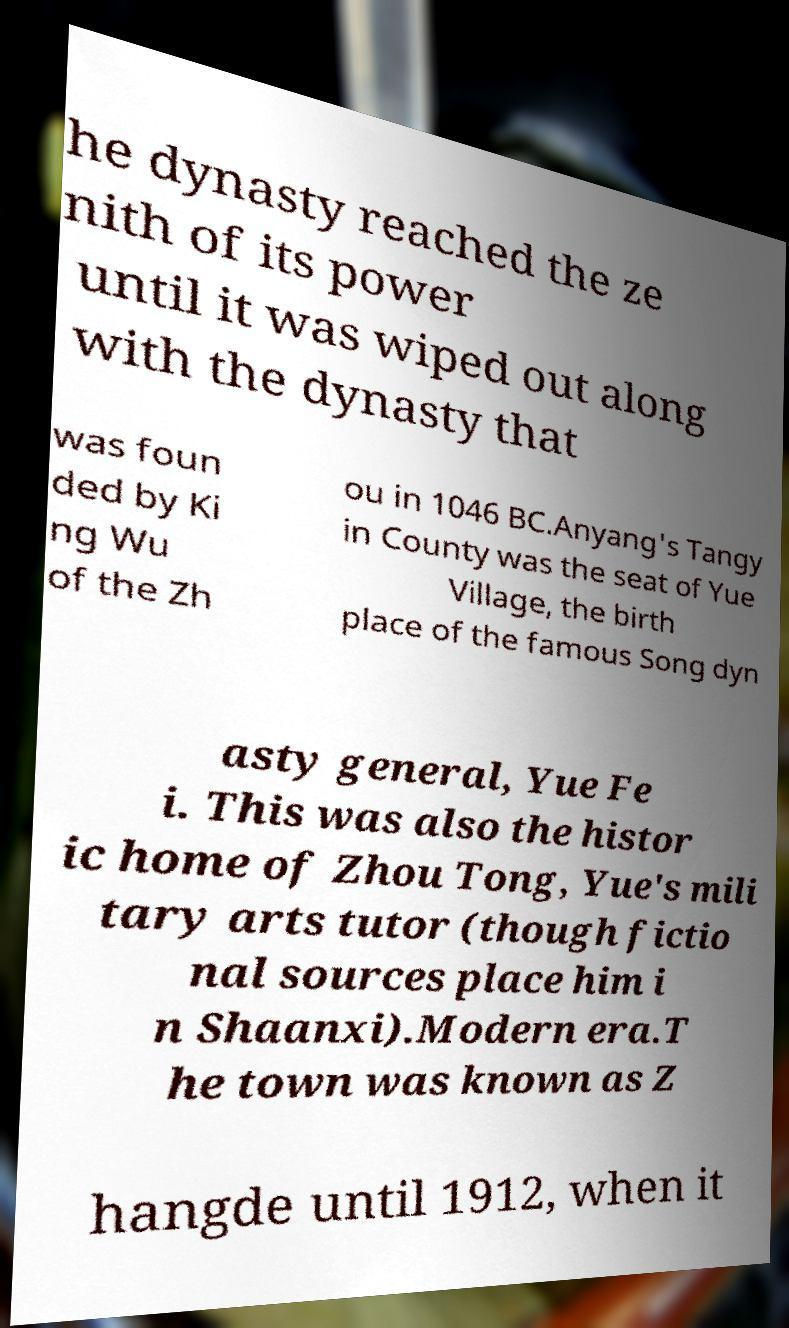Could you extract and type out the text from this image? he dynasty reached the ze nith of its power until it was wiped out along with the dynasty that was foun ded by Ki ng Wu of the Zh ou in 1046 BC.Anyang's Tangy in County was the seat of Yue Village, the birth place of the famous Song dyn asty general, Yue Fe i. This was also the histor ic home of Zhou Tong, Yue's mili tary arts tutor (though fictio nal sources place him i n Shaanxi).Modern era.T he town was known as Z hangde until 1912, when it 